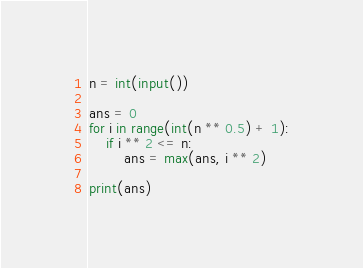Convert code to text. <code><loc_0><loc_0><loc_500><loc_500><_Python_>n = int(input())

ans = 0
for i in range(int(n ** 0.5) + 1):
    if i ** 2 <= n:
        ans = max(ans, i ** 2)

print(ans)
</code> 